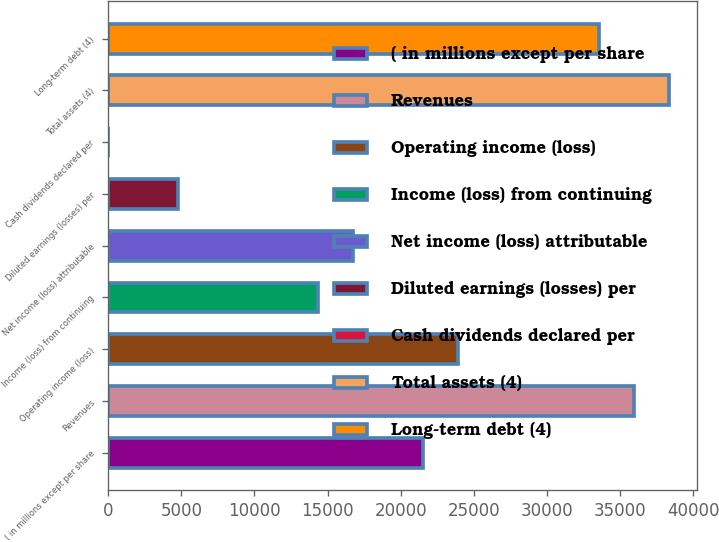Convert chart. <chart><loc_0><loc_0><loc_500><loc_500><bar_chart><fcel>( in millions except per share<fcel>Revenues<fcel>Operating income (loss)<fcel>Income (loss) from continuing<fcel>Net income (loss) attributable<fcel>Diluted earnings (losses) per<fcel>Cash dividends declared per<fcel>Total assets (4)<fcel>Long-term debt (4)<nl><fcel>21553.3<fcel>35921.3<fcel>23948<fcel>14369.3<fcel>16764<fcel>4790.63<fcel>1.29<fcel>38316<fcel>33526.7<nl></chart> 